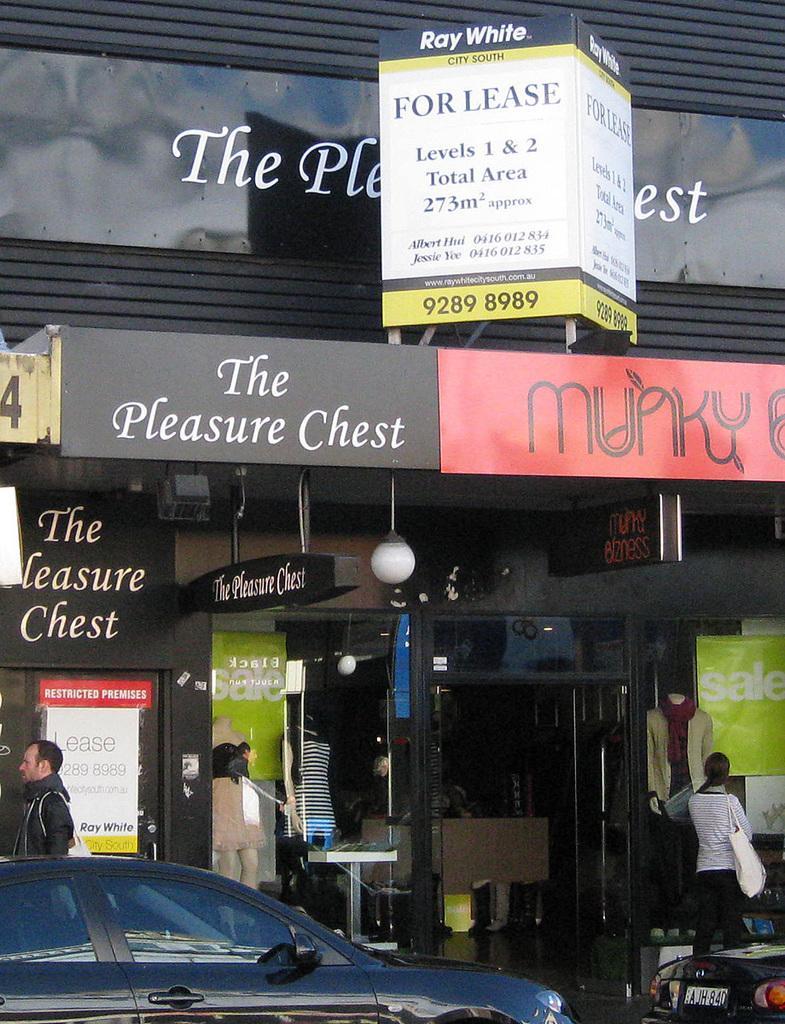Can you describe this image briefly? As we can see in the image there are buildings, few people here and there, banners and cars. 